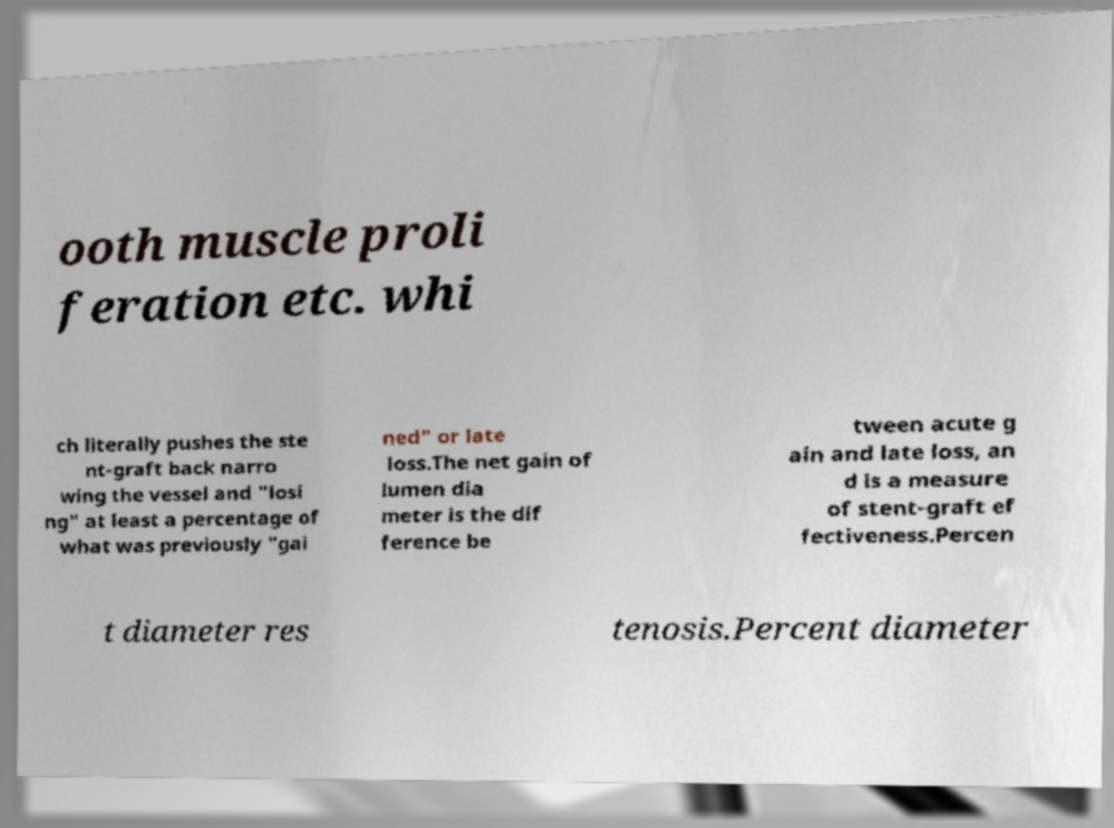Please identify and transcribe the text found in this image. ooth muscle proli feration etc. whi ch literally pushes the ste nt-graft back narro wing the vessel and "losi ng" at least a percentage of what was previously "gai ned" or late loss.The net gain of lumen dia meter is the dif ference be tween acute g ain and late loss, an d is a measure of stent-graft ef fectiveness.Percen t diameter res tenosis.Percent diameter 